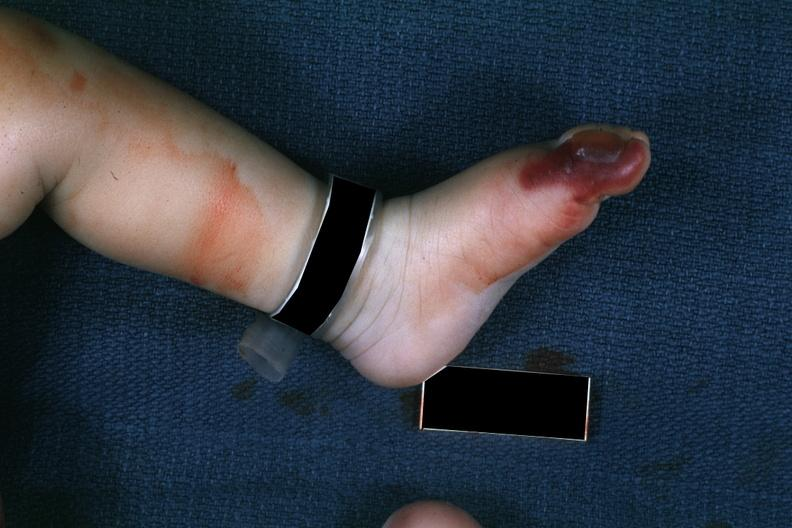re extremities present?
Answer the question using a single word or phrase. Yes 